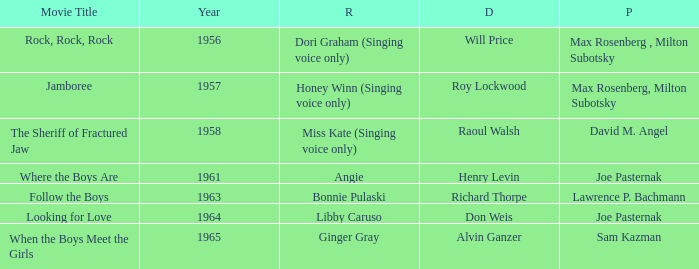What were the roles in 1961? Angie. Can you parse all the data within this table? {'header': ['Movie Title', 'Year', 'R', 'D', 'P'], 'rows': [['Rock, Rock, Rock', '1956', 'Dori Graham (Singing voice only)', 'Will Price', 'Max Rosenberg , Milton Subotsky'], ['Jamboree', '1957', 'Honey Winn (Singing voice only)', 'Roy Lockwood', 'Max Rosenberg, Milton Subotsky'], ['The Sheriff of Fractured Jaw', '1958', 'Miss Kate (Singing voice only)', 'Raoul Walsh', 'David M. Angel'], ['Where the Boys Are', '1961', 'Angie', 'Henry Levin', 'Joe Pasternak'], ['Follow the Boys', '1963', 'Bonnie Pulaski', 'Richard Thorpe', 'Lawrence P. Bachmann'], ['Looking for Love', '1964', 'Libby Caruso', 'Don Weis', 'Joe Pasternak'], ['When the Boys Meet the Girls', '1965', 'Ginger Gray', 'Alvin Ganzer', 'Sam Kazman']]} 